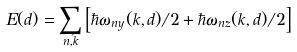<formula> <loc_0><loc_0><loc_500><loc_500>E ( d ) = \sum _ { n , \vec { k } } \left [ \hbar { \omega } _ { n y } ( k , d ) / 2 + \hbar { \omega } _ { n z } ( k , d ) / 2 \right ]</formula> 